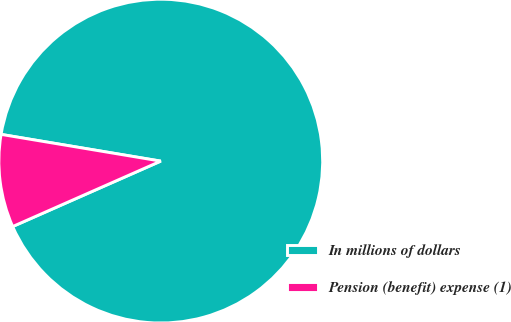<chart> <loc_0><loc_0><loc_500><loc_500><pie_chart><fcel>In millions of dollars<fcel>Pension (benefit) expense (1)<nl><fcel>90.74%<fcel>9.26%<nl></chart> 